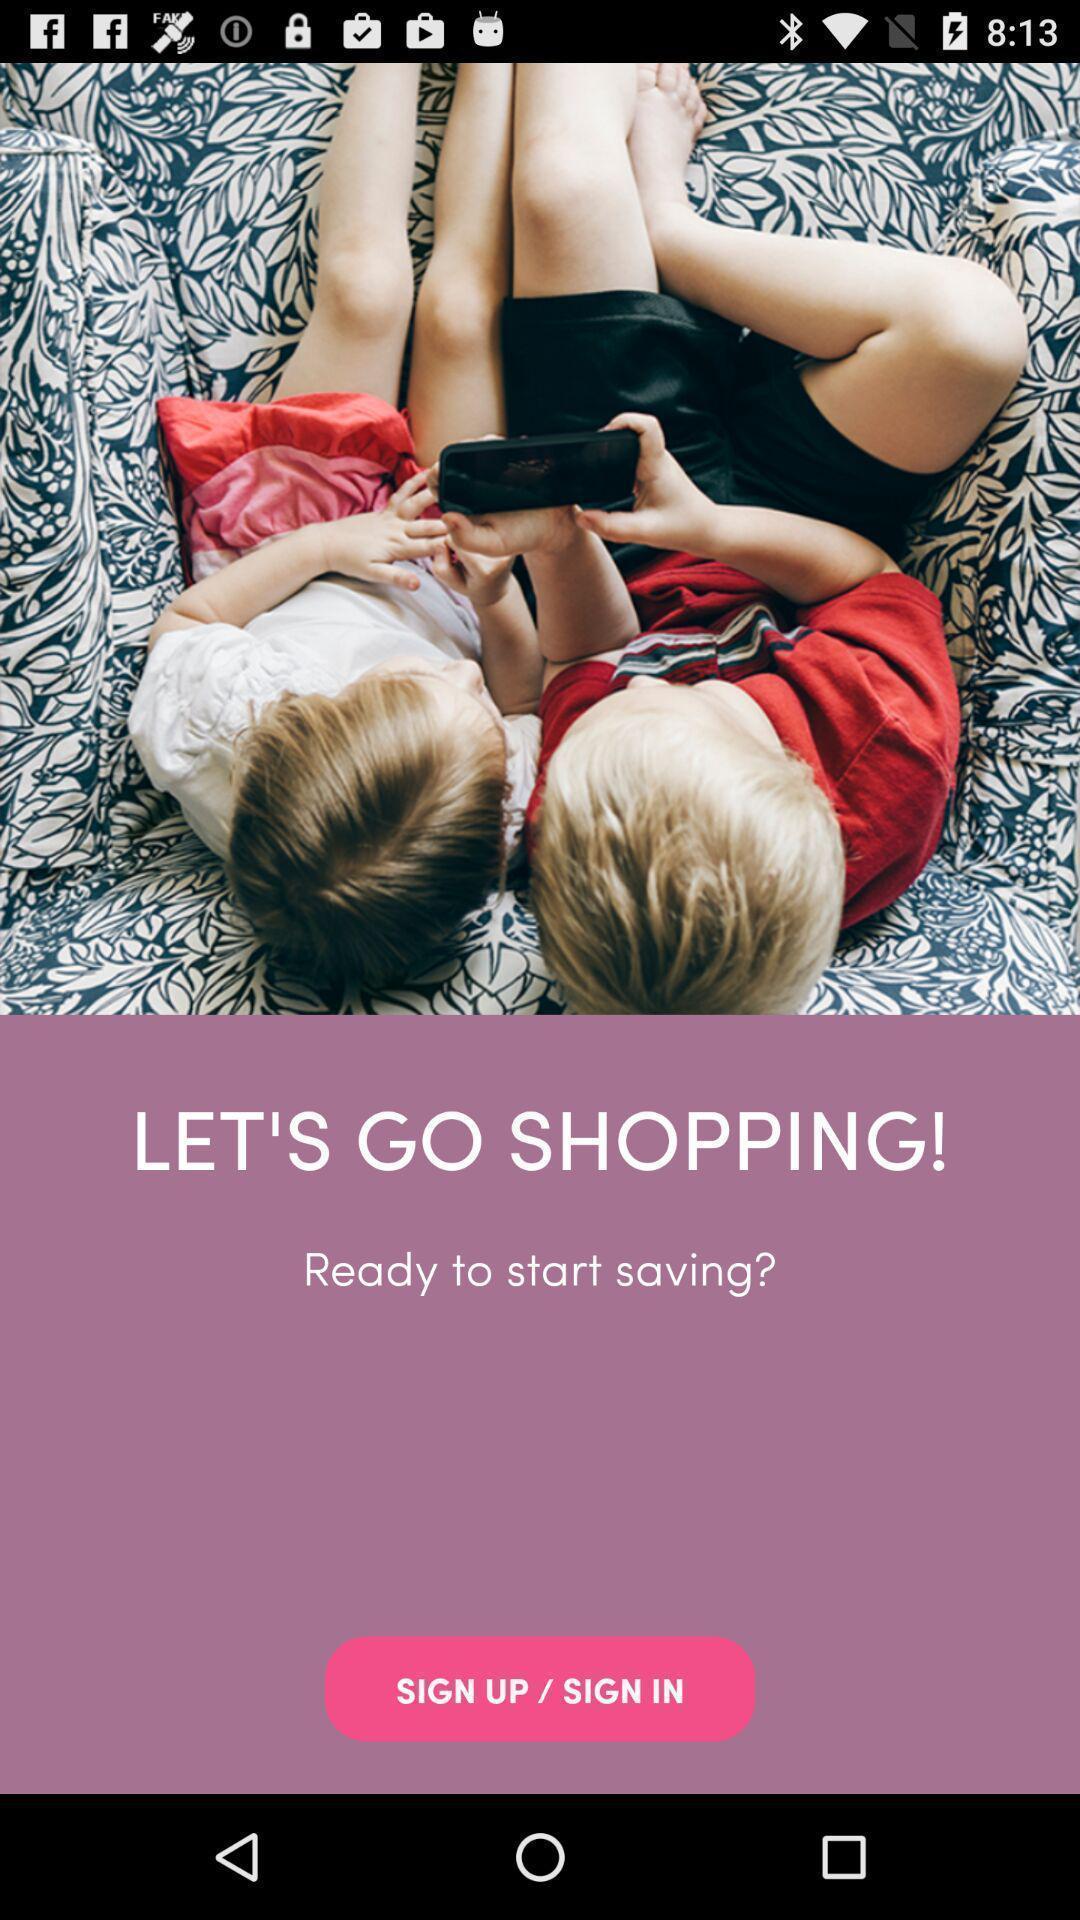What is the overall content of this screenshot? Sign up page of a social app. 